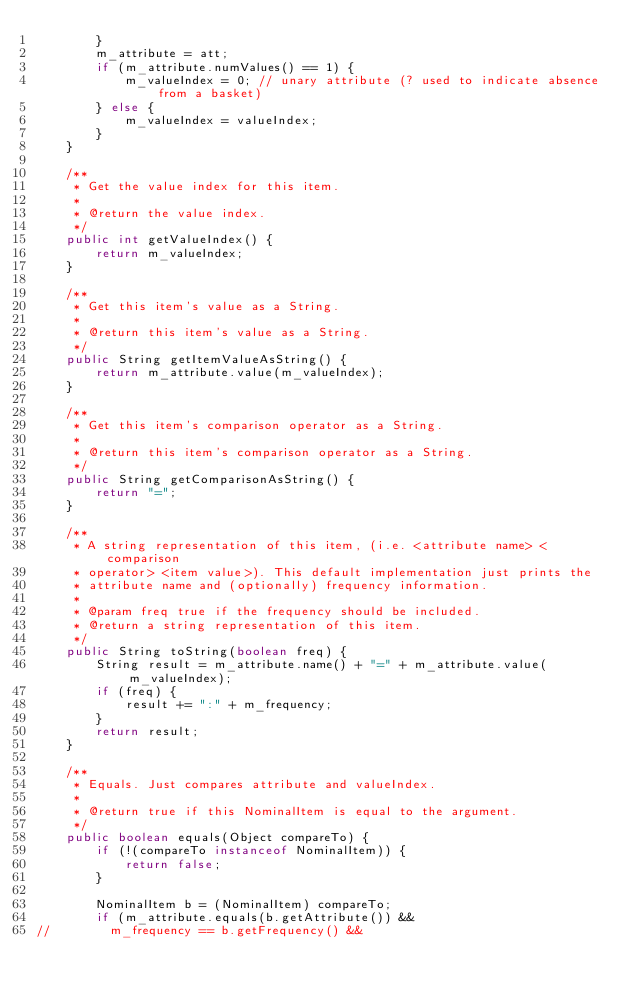Convert code to text. <code><loc_0><loc_0><loc_500><loc_500><_Java_>        }
        m_attribute = att;
        if (m_attribute.numValues() == 1) {
            m_valueIndex = 0; // unary attribute (? used to indicate absence from a basket)
        } else {
            m_valueIndex = valueIndex;
        }
    }

    /**
     * Get the value index for this item.
     * 
     * @return the value index.
     */
    public int getValueIndex() {
        return m_valueIndex;
    }

    /**
     * Get this item's value as a String.
     * 
     * @return this item's value as a String.
     */
    public String getItemValueAsString() {
        return m_attribute.value(m_valueIndex);
    }

    /**
     * Get this item's comparison operator as a String.
     * 
     * @return this item's comparison operator as a String.
     */
    public String getComparisonAsString() {
        return "=";
    }

    /**
     * A string representation of this item, (i.e. <attribute name> <comparison
     * operator> <item value>). This default implementation just prints the
     * attribute name and (optionally) frequency information.
     * 
     * @param freq true if the frequency should be included.
     * @return a string representation of this item.
     */
    public String toString(boolean freq) {
        String result = m_attribute.name() + "=" + m_attribute.value(m_valueIndex);
        if (freq) {
            result += ":" + m_frequency;
        }
        return result;
    }

    /**
     * Equals. Just compares attribute and valueIndex.
     * 
     * @return true if this NominalItem is equal to the argument.
     */
    public boolean equals(Object compareTo) {
        if (!(compareTo instanceof NominalItem)) {
            return false;
        }

        NominalItem b = (NominalItem) compareTo;
        if (m_attribute.equals(b.getAttribute()) &&
//        m_frequency == b.getFrequency() && </code> 